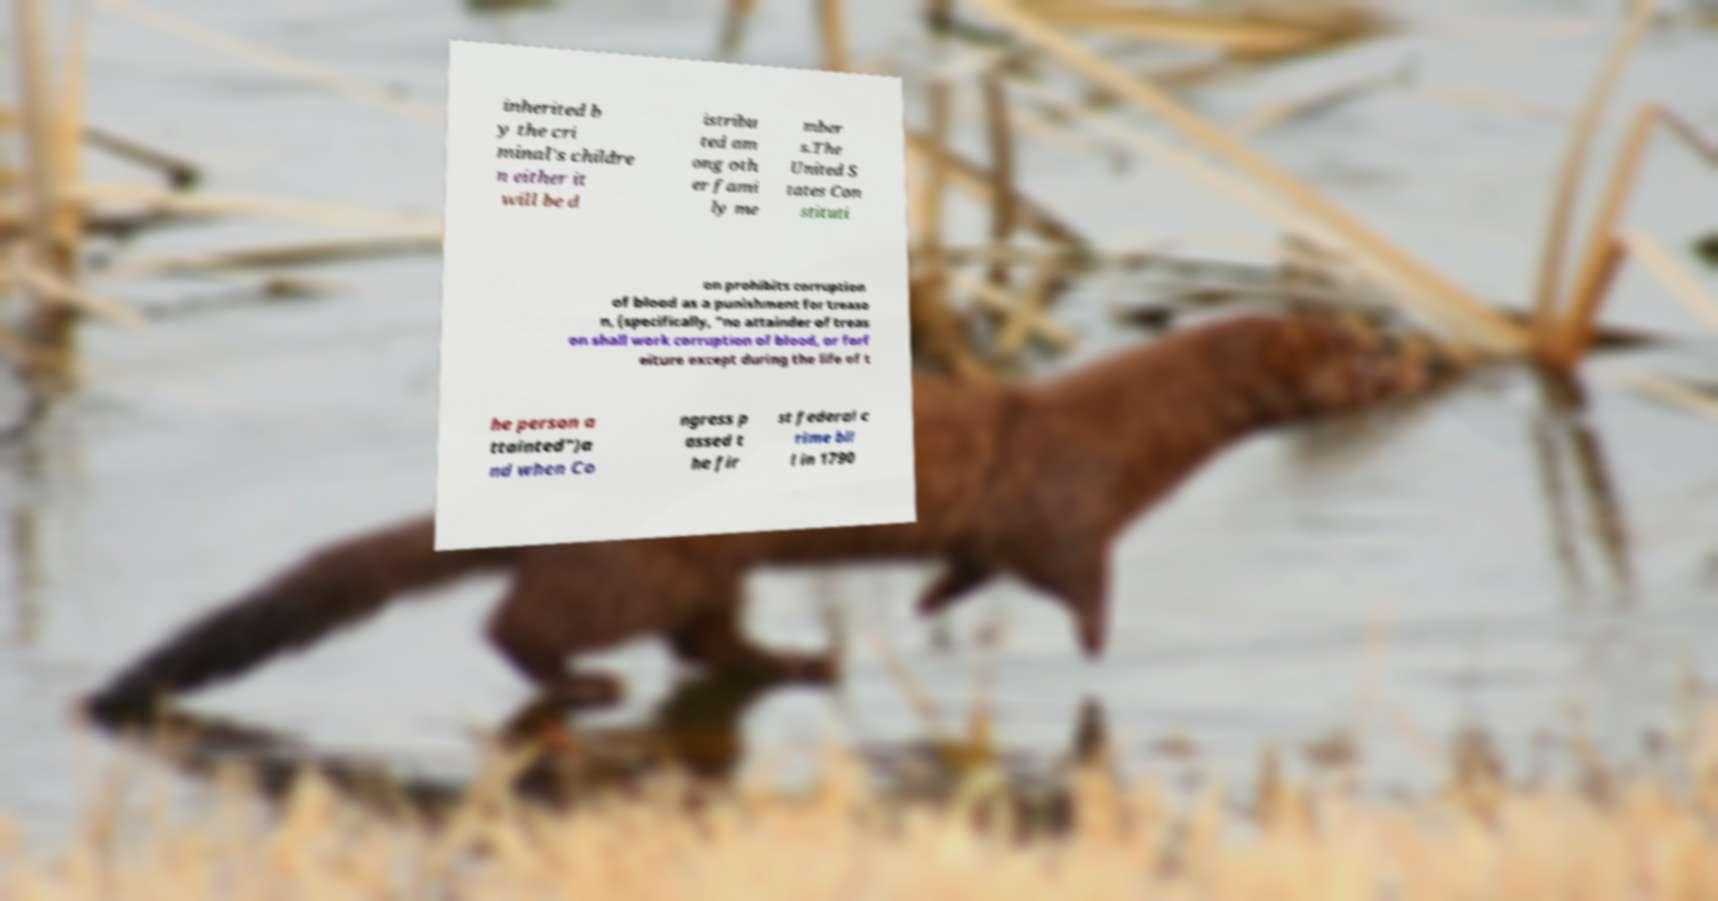For documentation purposes, I need the text within this image transcribed. Could you provide that? inherited b y the cri minal's childre n either it will be d istribu ted am ong oth er fami ly me mber s.The United S tates Con stituti on prohibits corruption of blood as a punishment for treaso n, (specifically, "no attainder of treas on shall work corruption of blood, or forf eiture except during the life of t he person a ttainted")a nd when Co ngress p assed t he fir st federal c rime bil l in 1790 